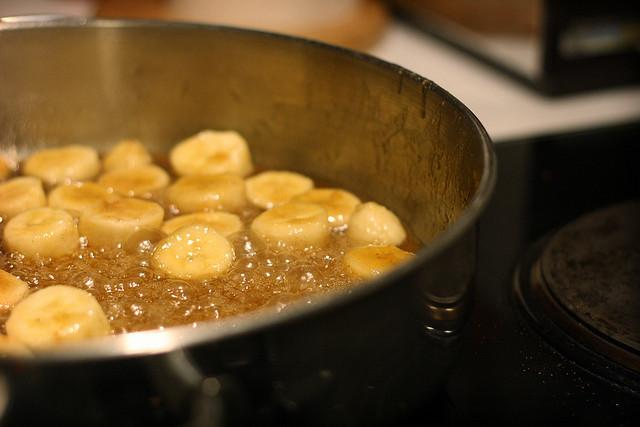What is this pan currently being used to create? Please explain your reasoning. dessert. These are bananas which are sweet and used in desserts. 